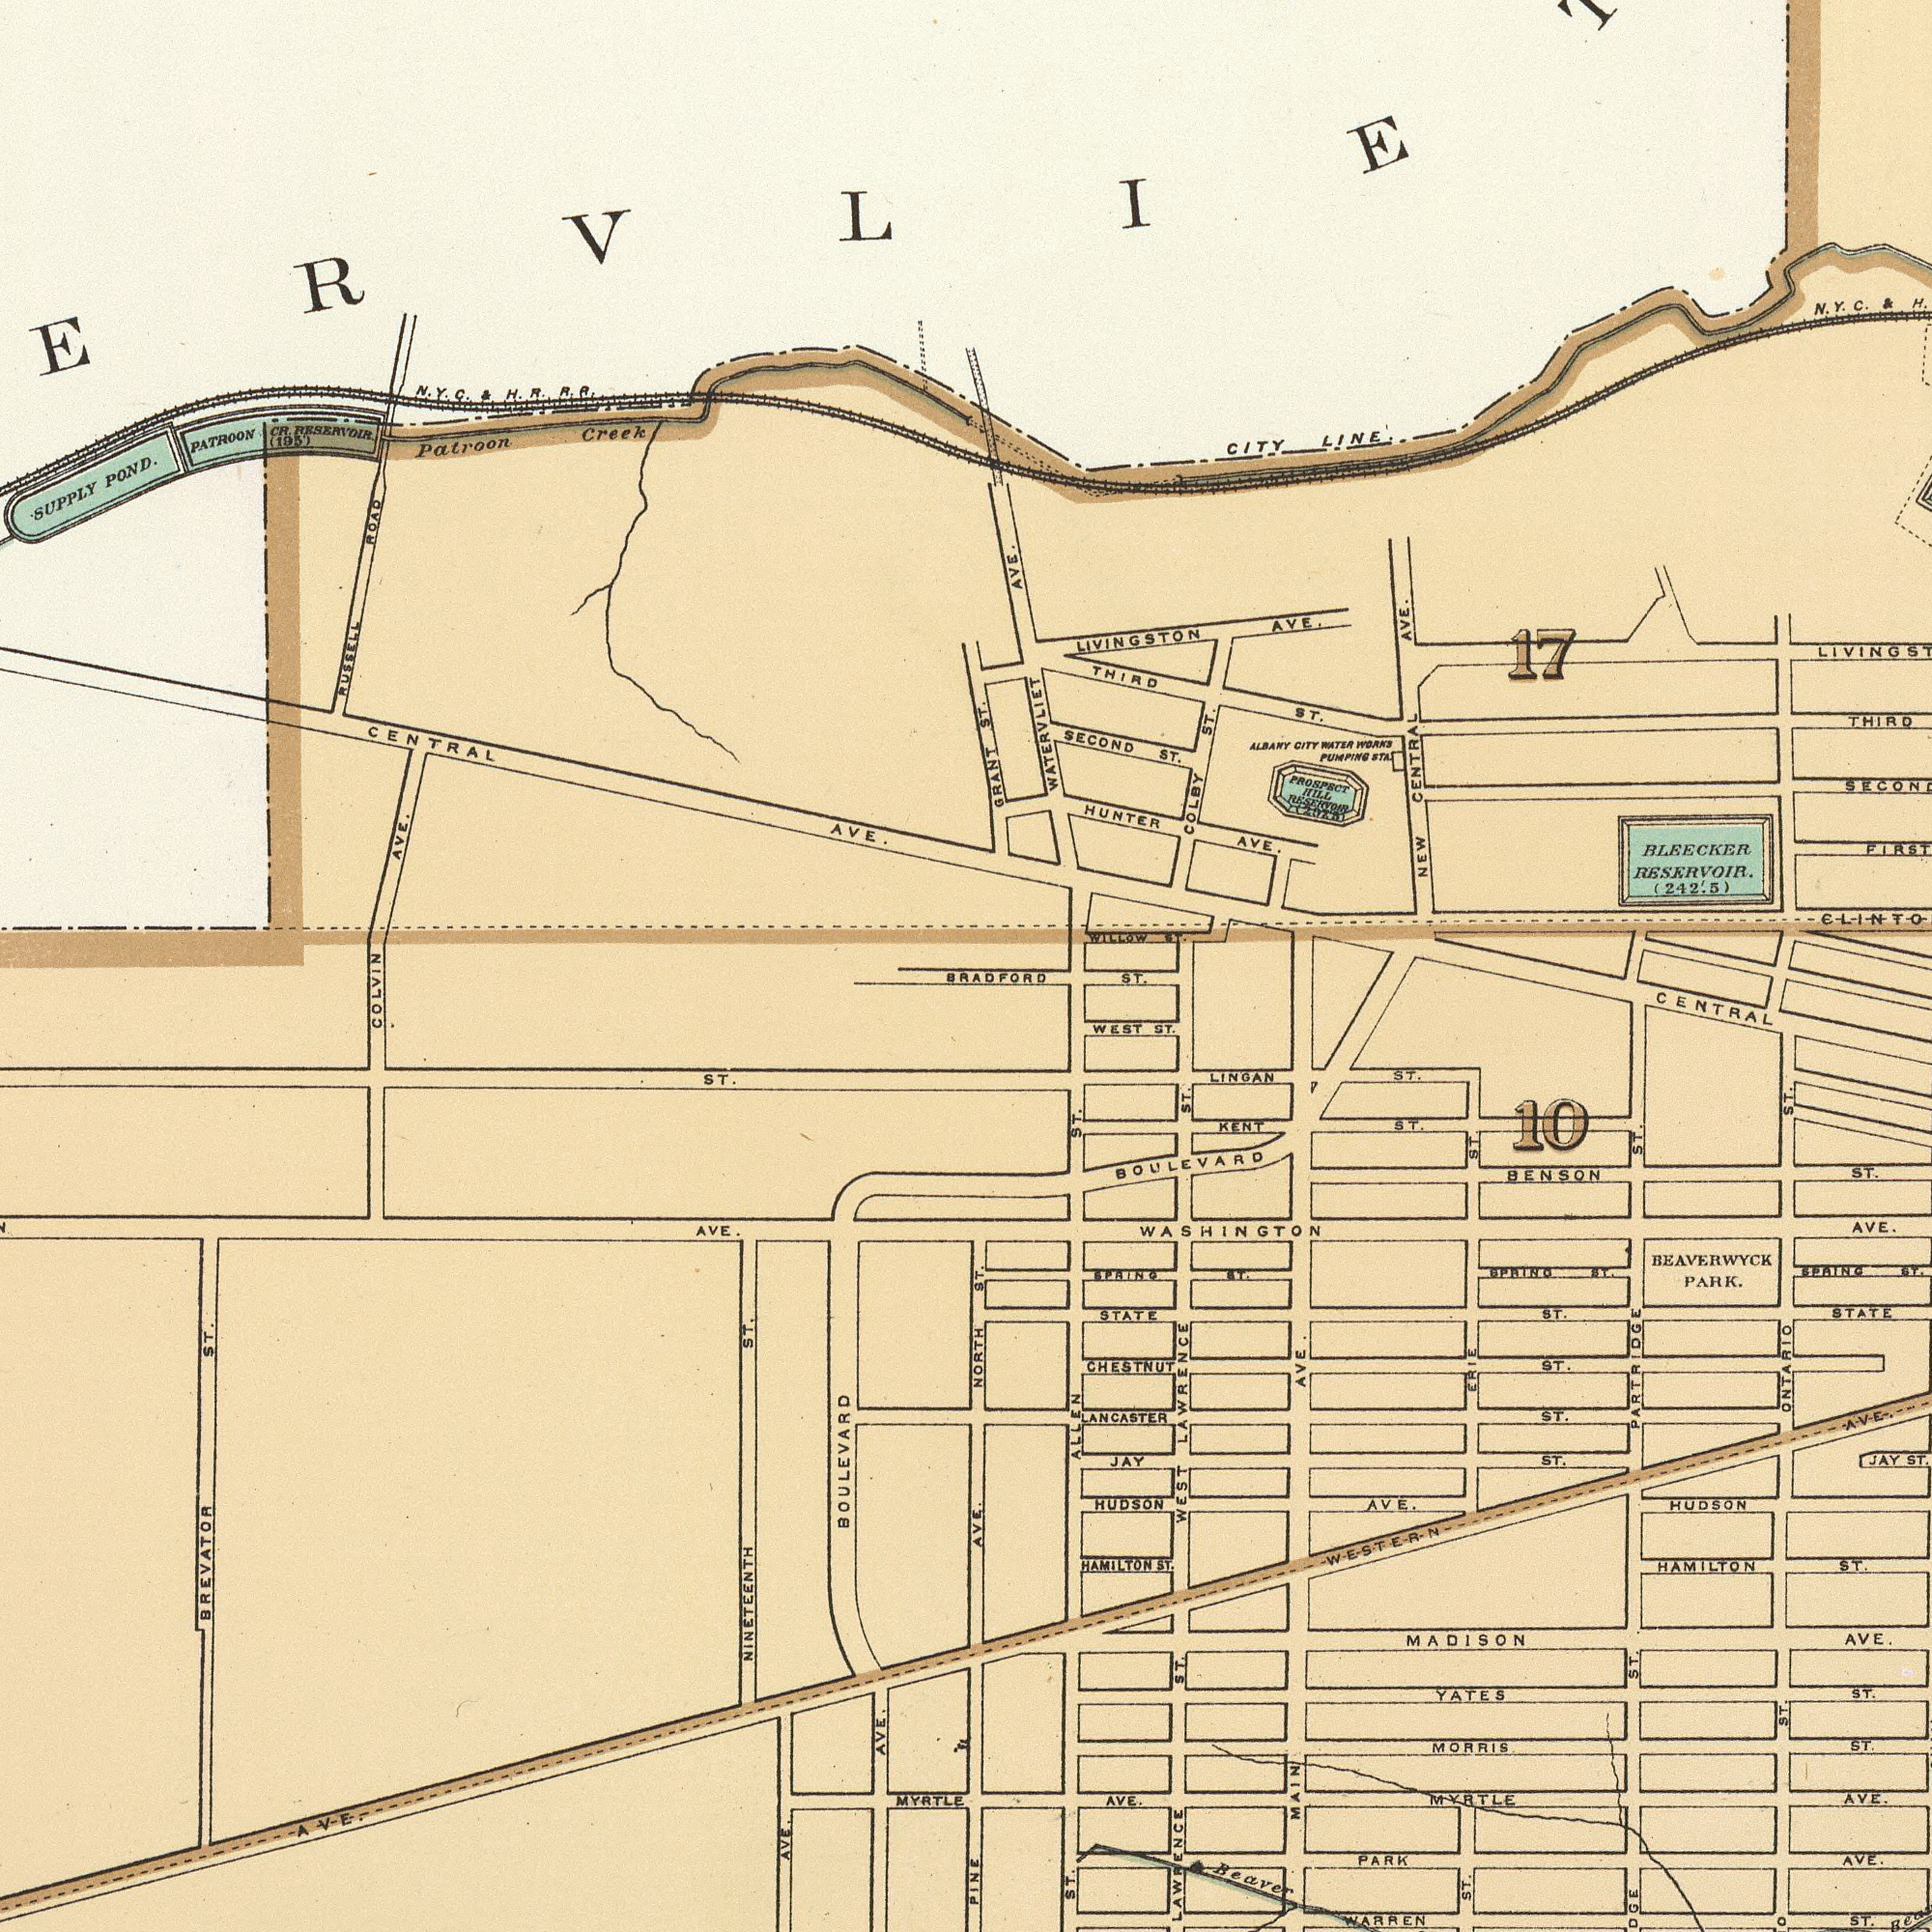What text appears in the top-right area of the image? FIRST NEW CENTRAL AVE. HUNTER AVE. COLBY ST. THIRD LIVINGSTON AVE. THIRD ST. SECOND ST. GRANT ST. CITY LINE. BLEECKER RESERVOIR (242.5) ALBANY CITY WATER WORNS PUMPING STA. WATERVLIET AVE. 17 LIVING ST WILLOW ST. CENTRAL ST. LINGAN ST. WEST ST. ST. BRADFORD ST. N. Y. C. & PROSPECT HILL RESERVOIR What text can you see in the top-left section? Patroon Creek .SUPPLY POND. CENTRAL AVE. COLVIN AVE. RUSSELL ROAD PATROON CR. RESERVOIR (195) ST. N. Y. C. &. H. R. R. R. What text appears in the bottom-left area of the image? BOULEVARD NINETEENTH ST. BREVATOR ST. MYRTLE AVE. AVE. AVE. AVE. PINE AVE. What text appears in the bottom-right area of the image? AVE. MADISON AVE. Beaver ALLEN ST. BOULEVARD MORRIS ST. LANCASTER ST. BEAVERWYCK PARK. 10 WASHINGTON AVE. STATE MYRTLE AVE. ONTARIO HAMILTON ST. JAY ST. MAIN AVE. WARREN ST. WEST LAWRENCE CHESTNUT ST. BENSON ST. KENT ST. HUDSON PARK AVE. STATE ST. ST. HUDSON AVE. SPAING ST YATES ST. SPAING ST. NORTH ST. LAWRENCE ST BPAING AT. WESTERN AVE. ERIE ST. JAY ST. PARTRIDGE ST. ST. HAMILTON ST. ST. ST. 